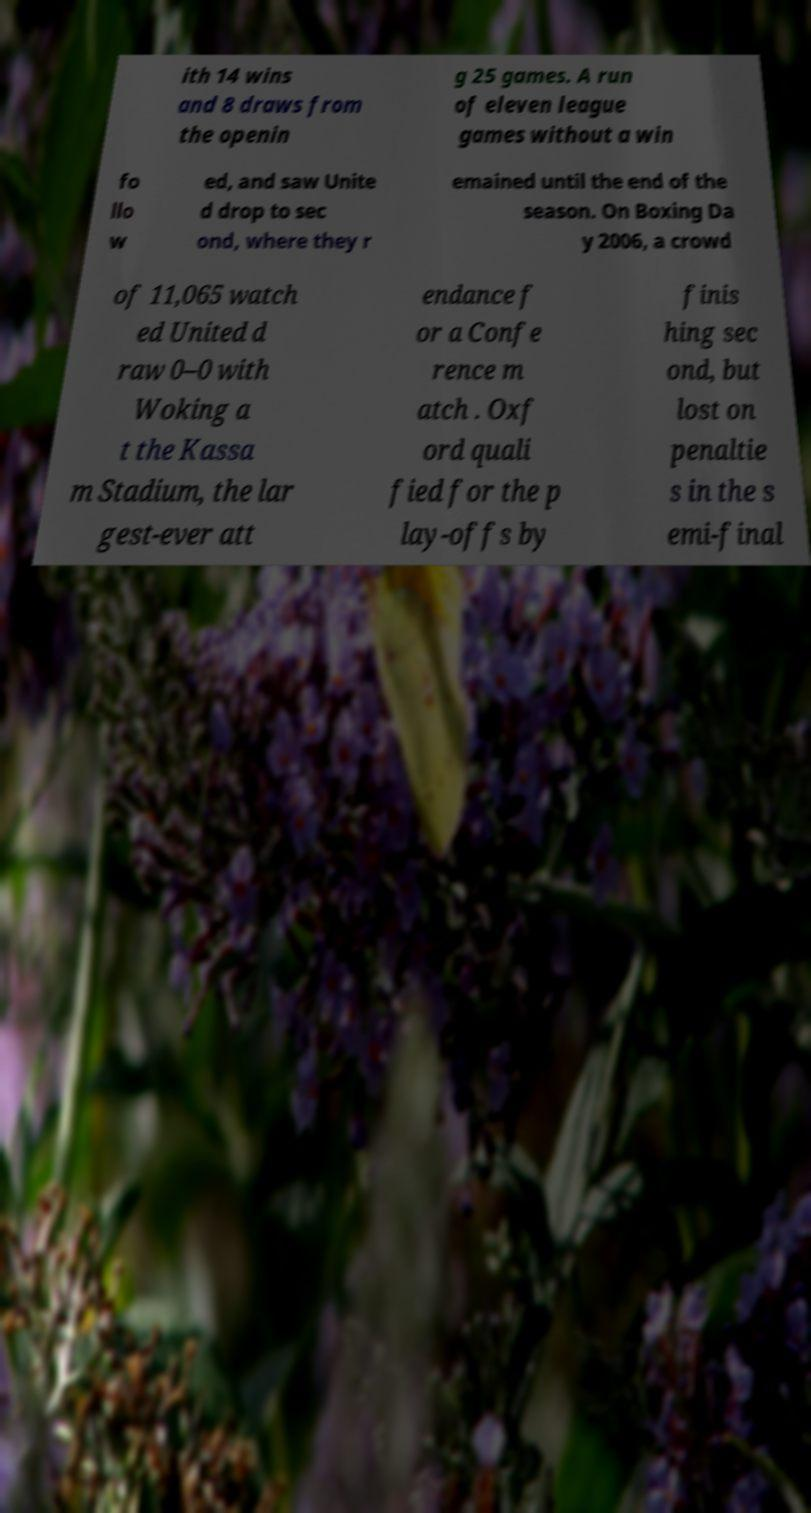Could you assist in decoding the text presented in this image and type it out clearly? ith 14 wins and 8 draws from the openin g 25 games. A run of eleven league games without a win fo llo w ed, and saw Unite d drop to sec ond, where they r emained until the end of the season. On Boxing Da y 2006, a crowd of 11,065 watch ed United d raw 0–0 with Woking a t the Kassa m Stadium, the lar gest-ever att endance f or a Confe rence m atch . Oxf ord quali fied for the p lay-offs by finis hing sec ond, but lost on penaltie s in the s emi-final 